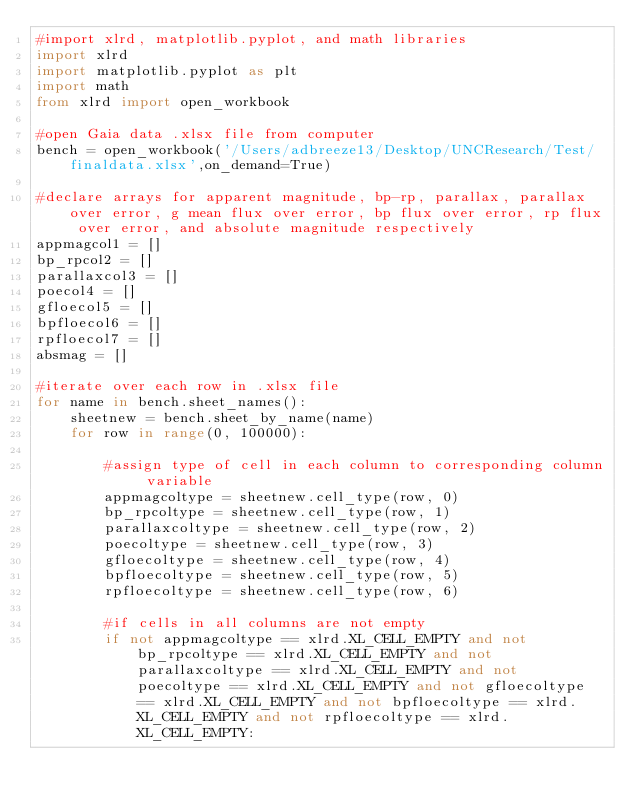Convert code to text. <code><loc_0><loc_0><loc_500><loc_500><_Python_>#import xlrd, matplotlib.pyplot, and math libraries
import xlrd
import matplotlib.pyplot as plt
import math 
from xlrd import open_workbook

#open Gaia data .xlsx file from computer
bench = open_workbook('/Users/adbreeze13/Desktop/UNCResearch/Test/finaldata.xlsx',on_demand=True)

#declare arrays for apparent magnitude, bp-rp, parallax, parallax over error, g mean flux over error, bp flux over error, rp flux over error, and absolute magnitude respectively
appmagcol1 = []
bp_rpcol2 = []
parallaxcol3 = []
poecol4 = []
gfloecol5 = []
bpfloecol6 = []
rpfloecol7 = []
absmag = []

#iterate over each row in .xlsx file
for name in bench.sheet_names():
    sheetnew = bench.sheet_by_name(name)
    for row in range(0, 100000):
        
        #assign type of cell in each column to corresponding column variable   
        appmagcoltype = sheetnew.cell_type(row, 0)
        bp_rpcoltype = sheetnew.cell_type(row, 1)
        parallaxcoltype = sheetnew.cell_type(row, 2)
        poecoltype = sheetnew.cell_type(row, 3)
        gfloecoltype = sheetnew.cell_type(row, 4)
        bpfloecoltype = sheetnew.cell_type(row, 5)
        rpfloecoltype = sheetnew.cell_type(row, 6)
        
        #if cells in all columns are not empty 
        if not appmagcoltype == xlrd.XL_CELL_EMPTY and not bp_rpcoltype == xlrd.XL_CELL_EMPTY and not parallaxcoltype == xlrd.XL_CELL_EMPTY and not poecoltype == xlrd.XL_CELL_EMPTY and not gfloecoltype == xlrd.XL_CELL_EMPTY and not bpfloecoltype == xlrd.XL_CELL_EMPTY and not rpfloecoltype == xlrd.XL_CELL_EMPTY:</code> 